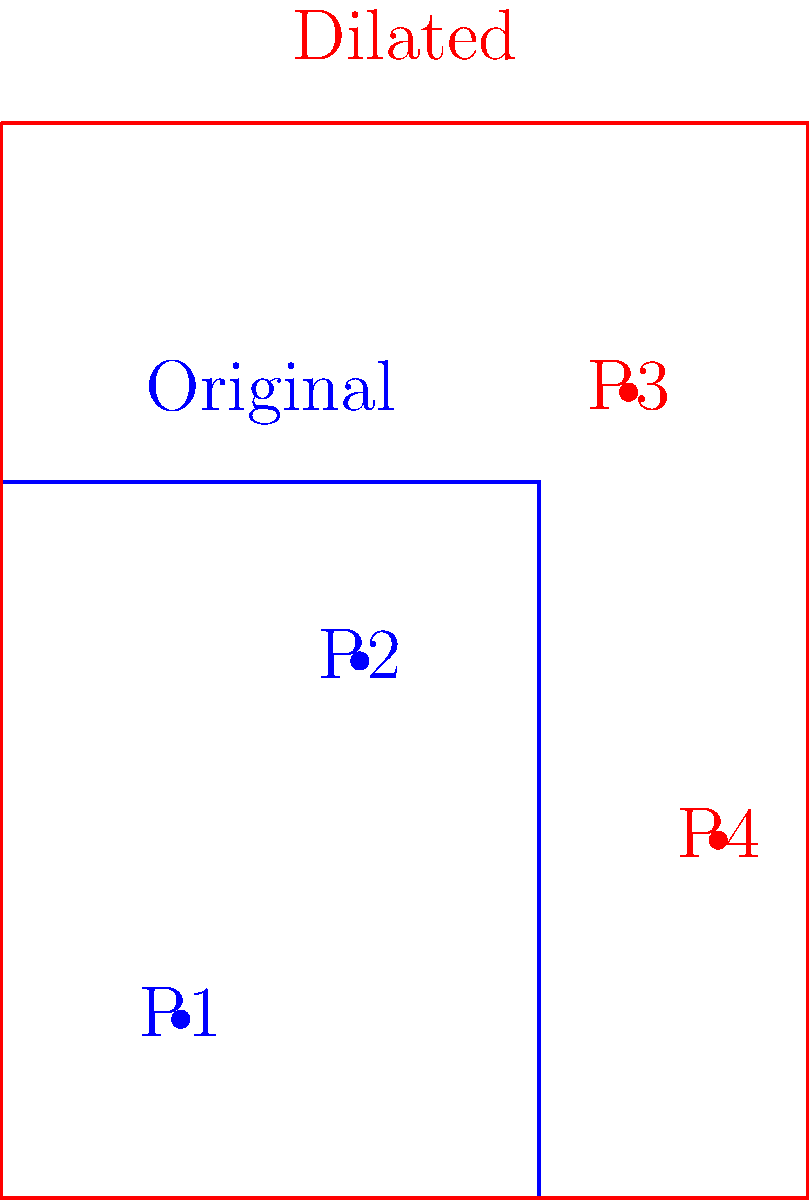As a former professional baseball player, you're analyzing the effects of dilating the strike zone. The original strike zone is represented by the blue rectangle, and the dilated strike zone is shown in red. The dilation factor is 1.5 from the bottom-left corner. Four pitches (P1, P2, P3, and P4) are plotted on the diagram. How many of these pitches would change from balls to strikes or vice versa due to the dilation of the strike zone? To solve this problem, we need to analyze each pitch location in relation to both the original and dilated strike zones:

1. Understand the dilation:
   - The strike zone is dilated by a factor of 1.5 from the bottom-left corner.
   - This means the width increases from 3 units to 4.5 units, and the height from 4 units to 6 units.

2. Analyze each pitch:
   - P1 (1,1): Inside both the original and dilated strike zones. No change.
   - P2 (2,3): Inside both the original and dilated strike zones. No change.
   - P3 (3.5,4.5): Outside the original strike zone but inside the dilated one. Changes from a ball to a strike.
   - P4 (4,2): Outside the original strike zone but inside the dilated one. Changes from a ball to a strike.

3. Count the changes:
   - P1 and P2 remain unchanged.
   - P3 and P4 both change from balls to strikes.

Therefore, 2 pitches would change their classification due to the dilation of the strike zone.
Answer: 2 pitches 